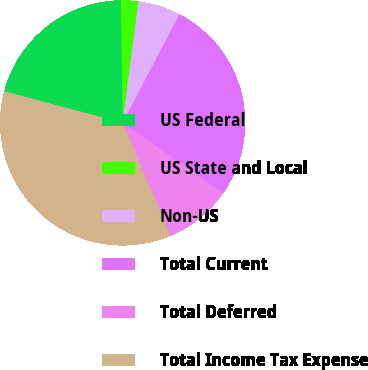Convert chart to OTSL. <chart><loc_0><loc_0><loc_500><loc_500><pie_chart><fcel>US Federal<fcel>US State and Local<fcel>Non-US<fcel>Total Current<fcel>Total Deferred<fcel>Total Income Tax Expense<nl><fcel>20.63%<fcel>2.28%<fcel>5.61%<fcel>27.01%<fcel>8.93%<fcel>35.54%<nl></chart> 